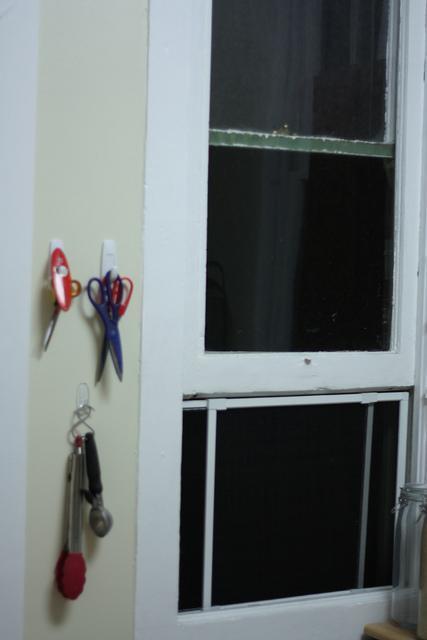How many pairs of scissor are in the photo?
Give a very brief answer. 2. How many window is there?
Give a very brief answer. 2. 